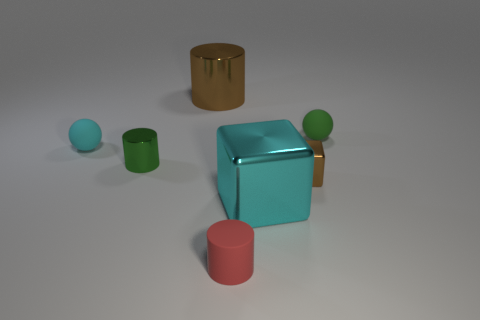Subtract all shiny cylinders. How many cylinders are left? 1 Add 1 big things. How many objects exist? 8 Subtract all green spheres. How many spheres are left? 1 Subtract 1 cubes. How many cubes are left? 1 Subtract all blocks. How many objects are left? 5 Subtract all purple shiny cylinders. Subtract all big cyan shiny objects. How many objects are left? 6 Add 3 green matte objects. How many green matte objects are left? 4 Add 4 cyan metal things. How many cyan metal things exist? 5 Subtract 1 brown cylinders. How many objects are left? 6 Subtract all blue spheres. Subtract all purple cubes. How many spheres are left? 2 